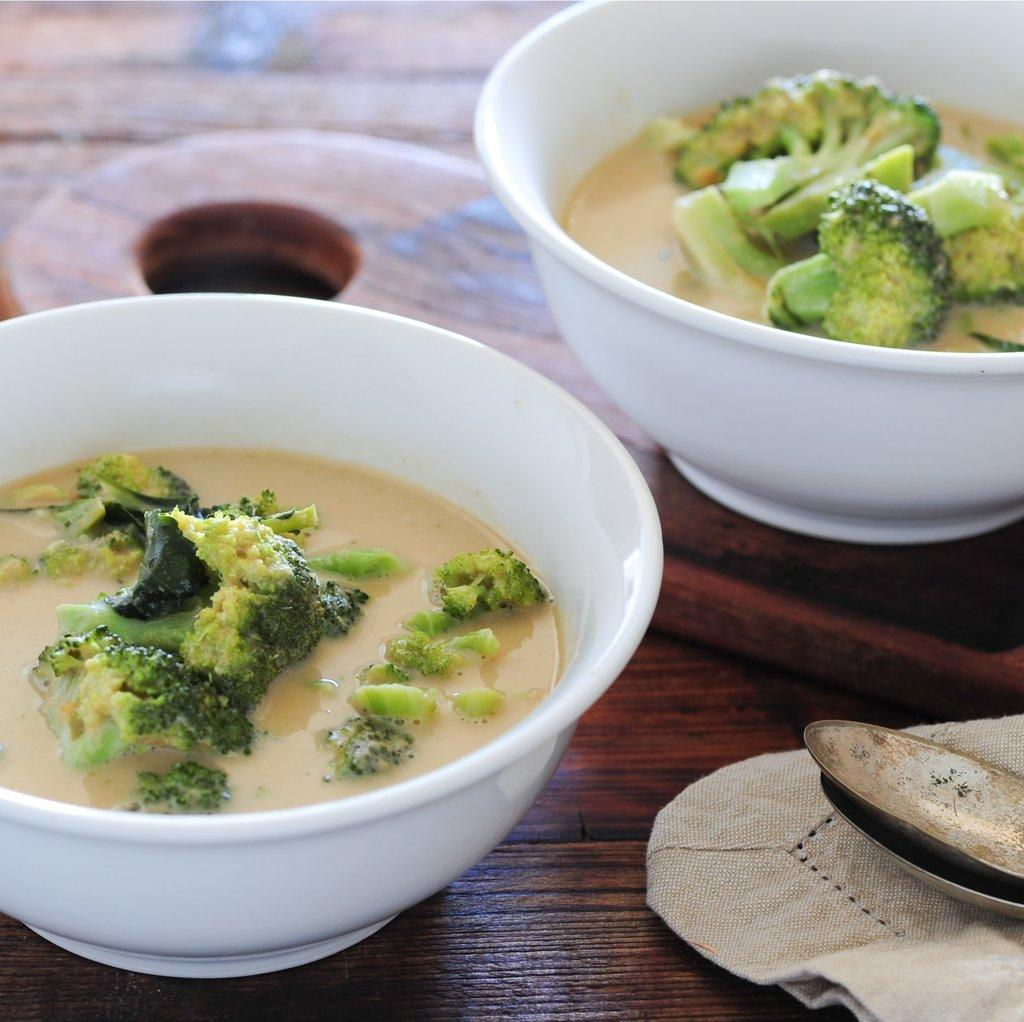What is in the bowls that are visible in the image? There are bowls containing food in the image. What color are the bowls? The bowls are white in color. Where are the bowls located in the image? The bowls are in the center of the image. What utensils can be seen in the image? There are spoons in the bottom right corner of the image. What else is present in the image besides the bowls and spoons? There is a cloth in the image. What type of heart can be seen beating in the image? There is no heart visible in the image; it features bowls containing food, white bowls, spoons, and a cloth. Can you tell me how many copies of the same bowl are present in the image? There is no indication of multiple copies of the same bowl in the image; it shows only one set of bowls containing food. 